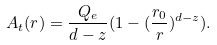<formula> <loc_0><loc_0><loc_500><loc_500>A _ { t } ( r ) = \frac { Q _ { e } } { d - z } ( 1 - ( \frac { r _ { 0 } } { r } ) ^ { d - z } ) .</formula> 